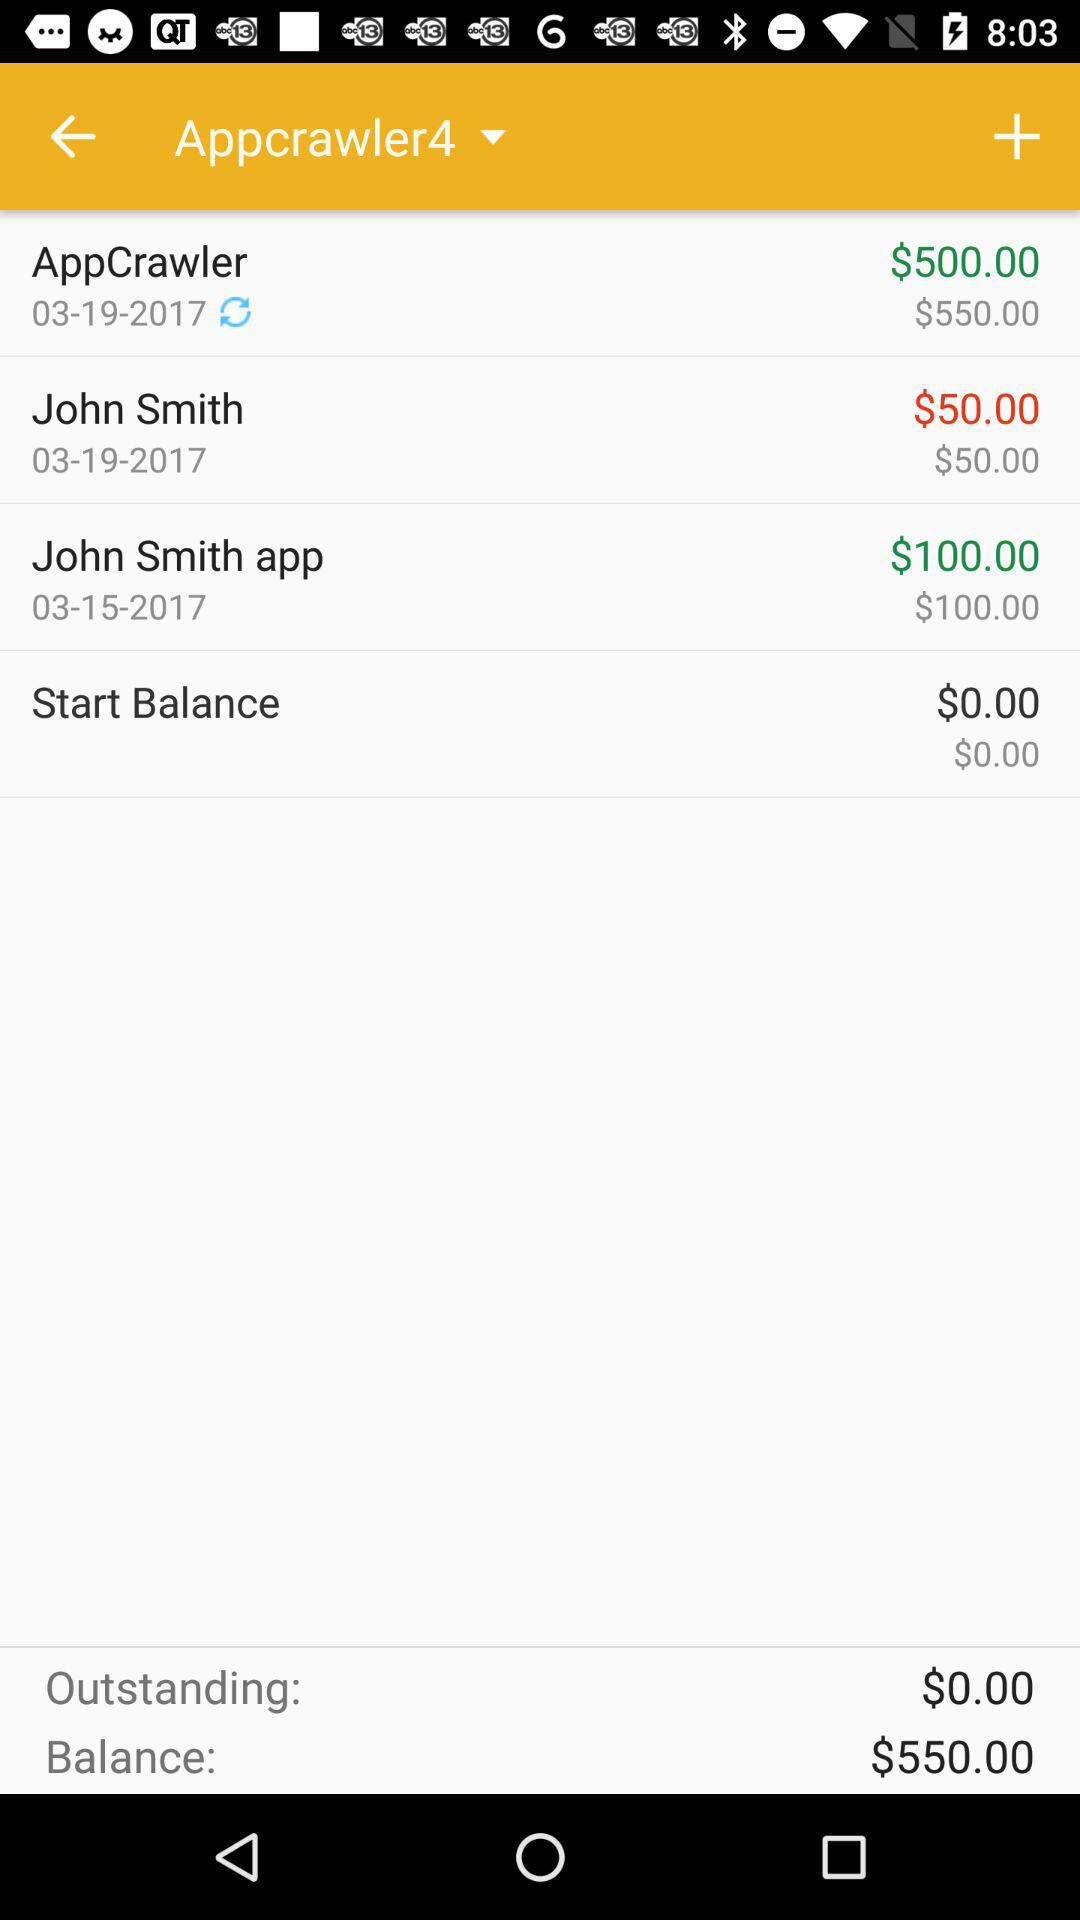How much is the total balance? The total balance is $550.00. 